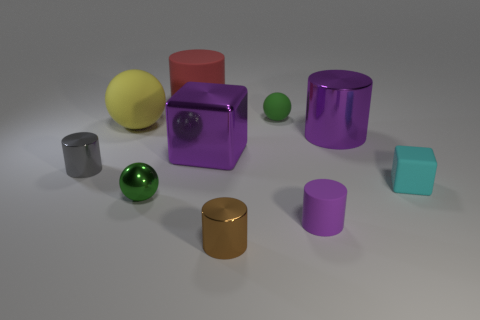Subtract all big yellow spheres. How many spheres are left? 2 Subtract all yellow spheres. How many spheres are left? 2 Subtract all cubes. How many objects are left? 8 Subtract 2 cylinders. How many cylinders are left? 3 Subtract 1 brown cylinders. How many objects are left? 9 Subtract all yellow cubes. Subtract all red spheres. How many cubes are left? 2 Subtract all purple blocks. How many blue spheres are left? 0 Subtract all tiny gray things. Subtract all tiny green balls. How many objects are left? 7 Add 6 big yellow objects. How many big yellow objects are left? 7 Add 5 big purple metallic cubes. How many big purple metallic cubes exist? 6 